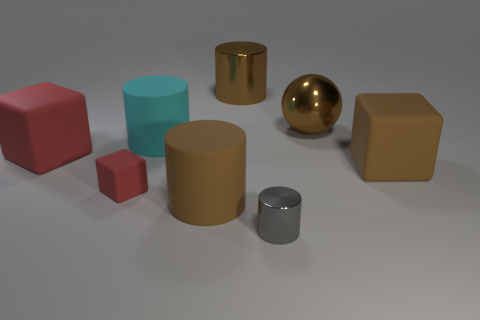Add 1 red matte cubes. How many objects exist? 9 Subtract all blocks. How many objects are left? 5 Add 4 small things. How many small things exist? 6 Subtract 0 red cylinders. How many objects are left? 8 Subtract all blocks. Subtract all large rubber cylinders. How many objects are left? 3 Add 1 big brown matte things. How many big brown matte things are left? 3 